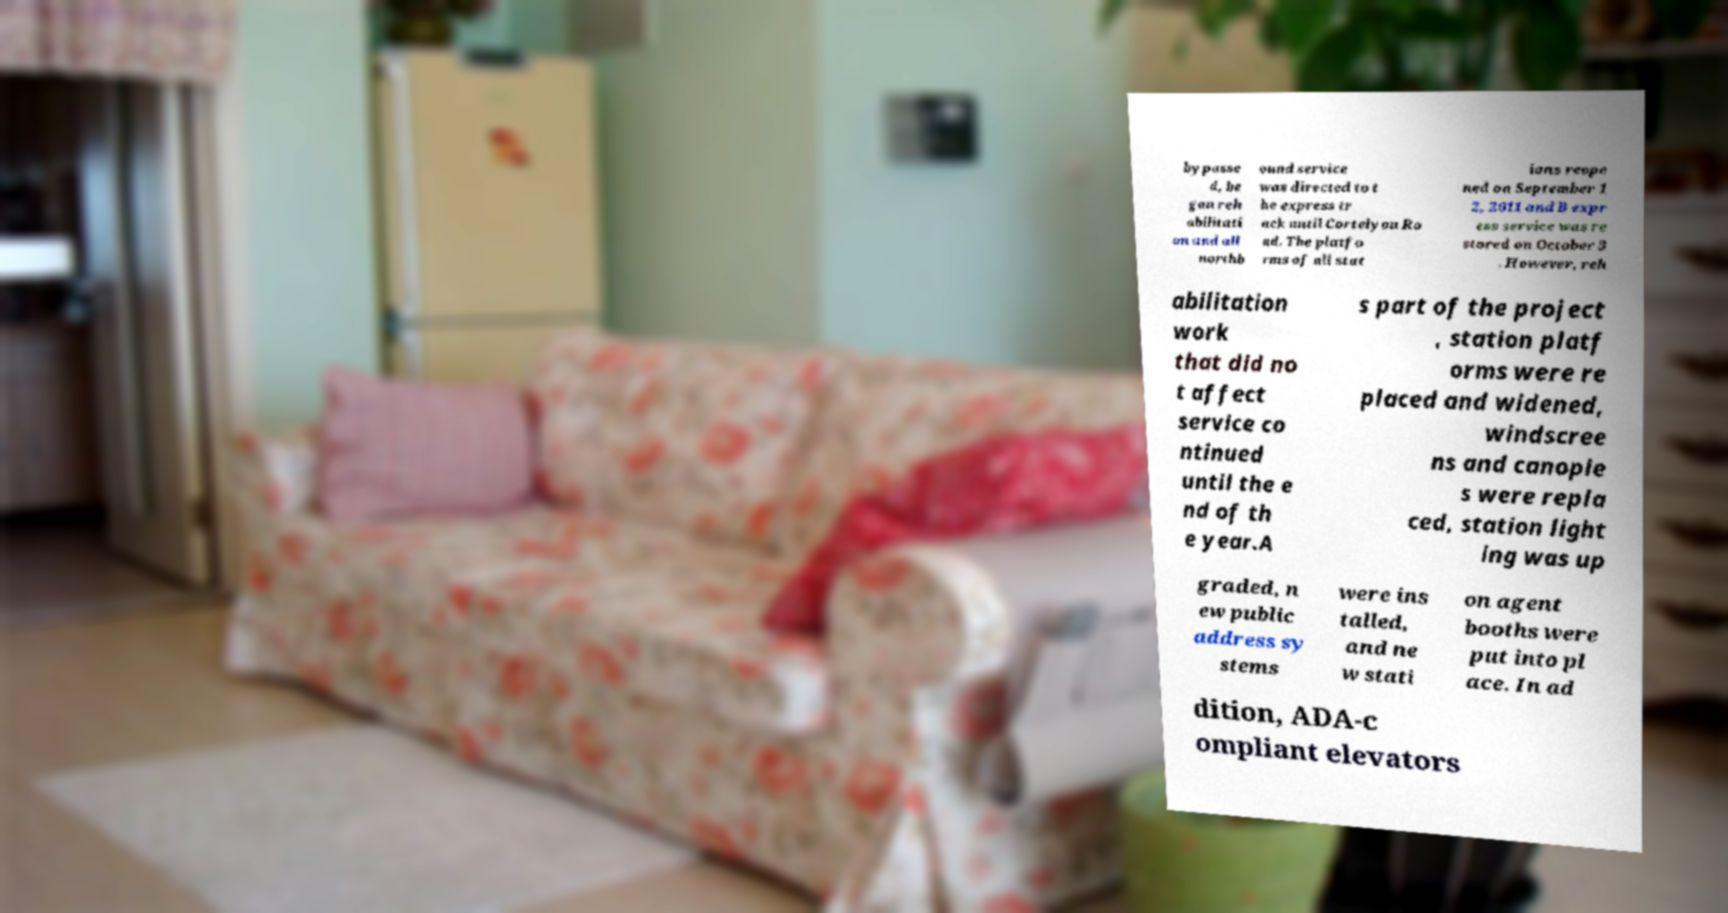Please identify and transcribe the text found in this image. bypasse d, be gan reh abilitati on and all northb ound service was directed to t he express tr ack until Cortelyou Ro ad. The platfo rms of all stat ions reope ned on September 1 2, 2011 and B expr ess service was re stored on October 3 . However, reh abilitation work that did no t affect service co ntinued until the e nd of th e year.A s part of the project , station platf orms were re placed and widened, windscree ns and canopie s were repla ced, station light ing was up graded, n ew public address sy stems were ins talled, and ne w stati on agent booths were put into pl ace. In ad dition, ADA-c ompliant elevators 